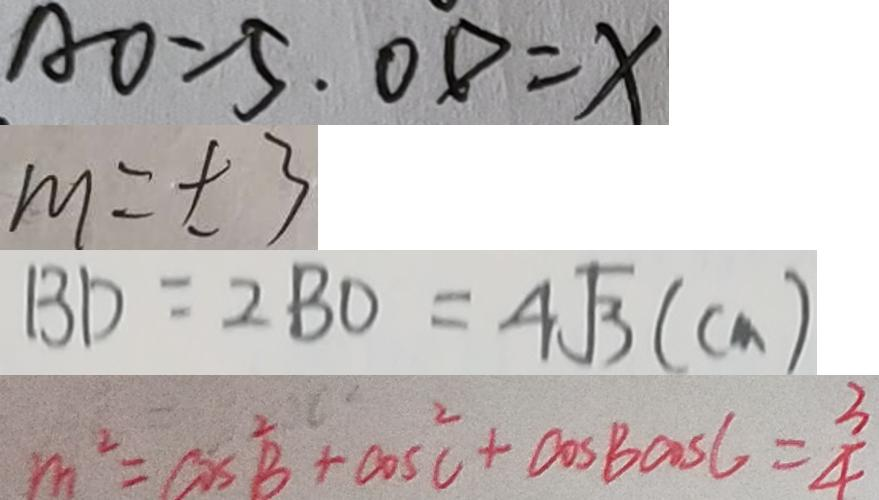<formula> <loc_0><loc_0><loc_500><loc_500>A O = 5 . O D = x 
 m = \pm 3 
 B D = 2 B O = 4 \sqrt { 3 } ( c m ) 
 m ^ { 2 } = \cos ^ { 2 } B + \cos ^ { 2 } C + \cos B \cos C = \frac { 3 } { 4 }</formula> 